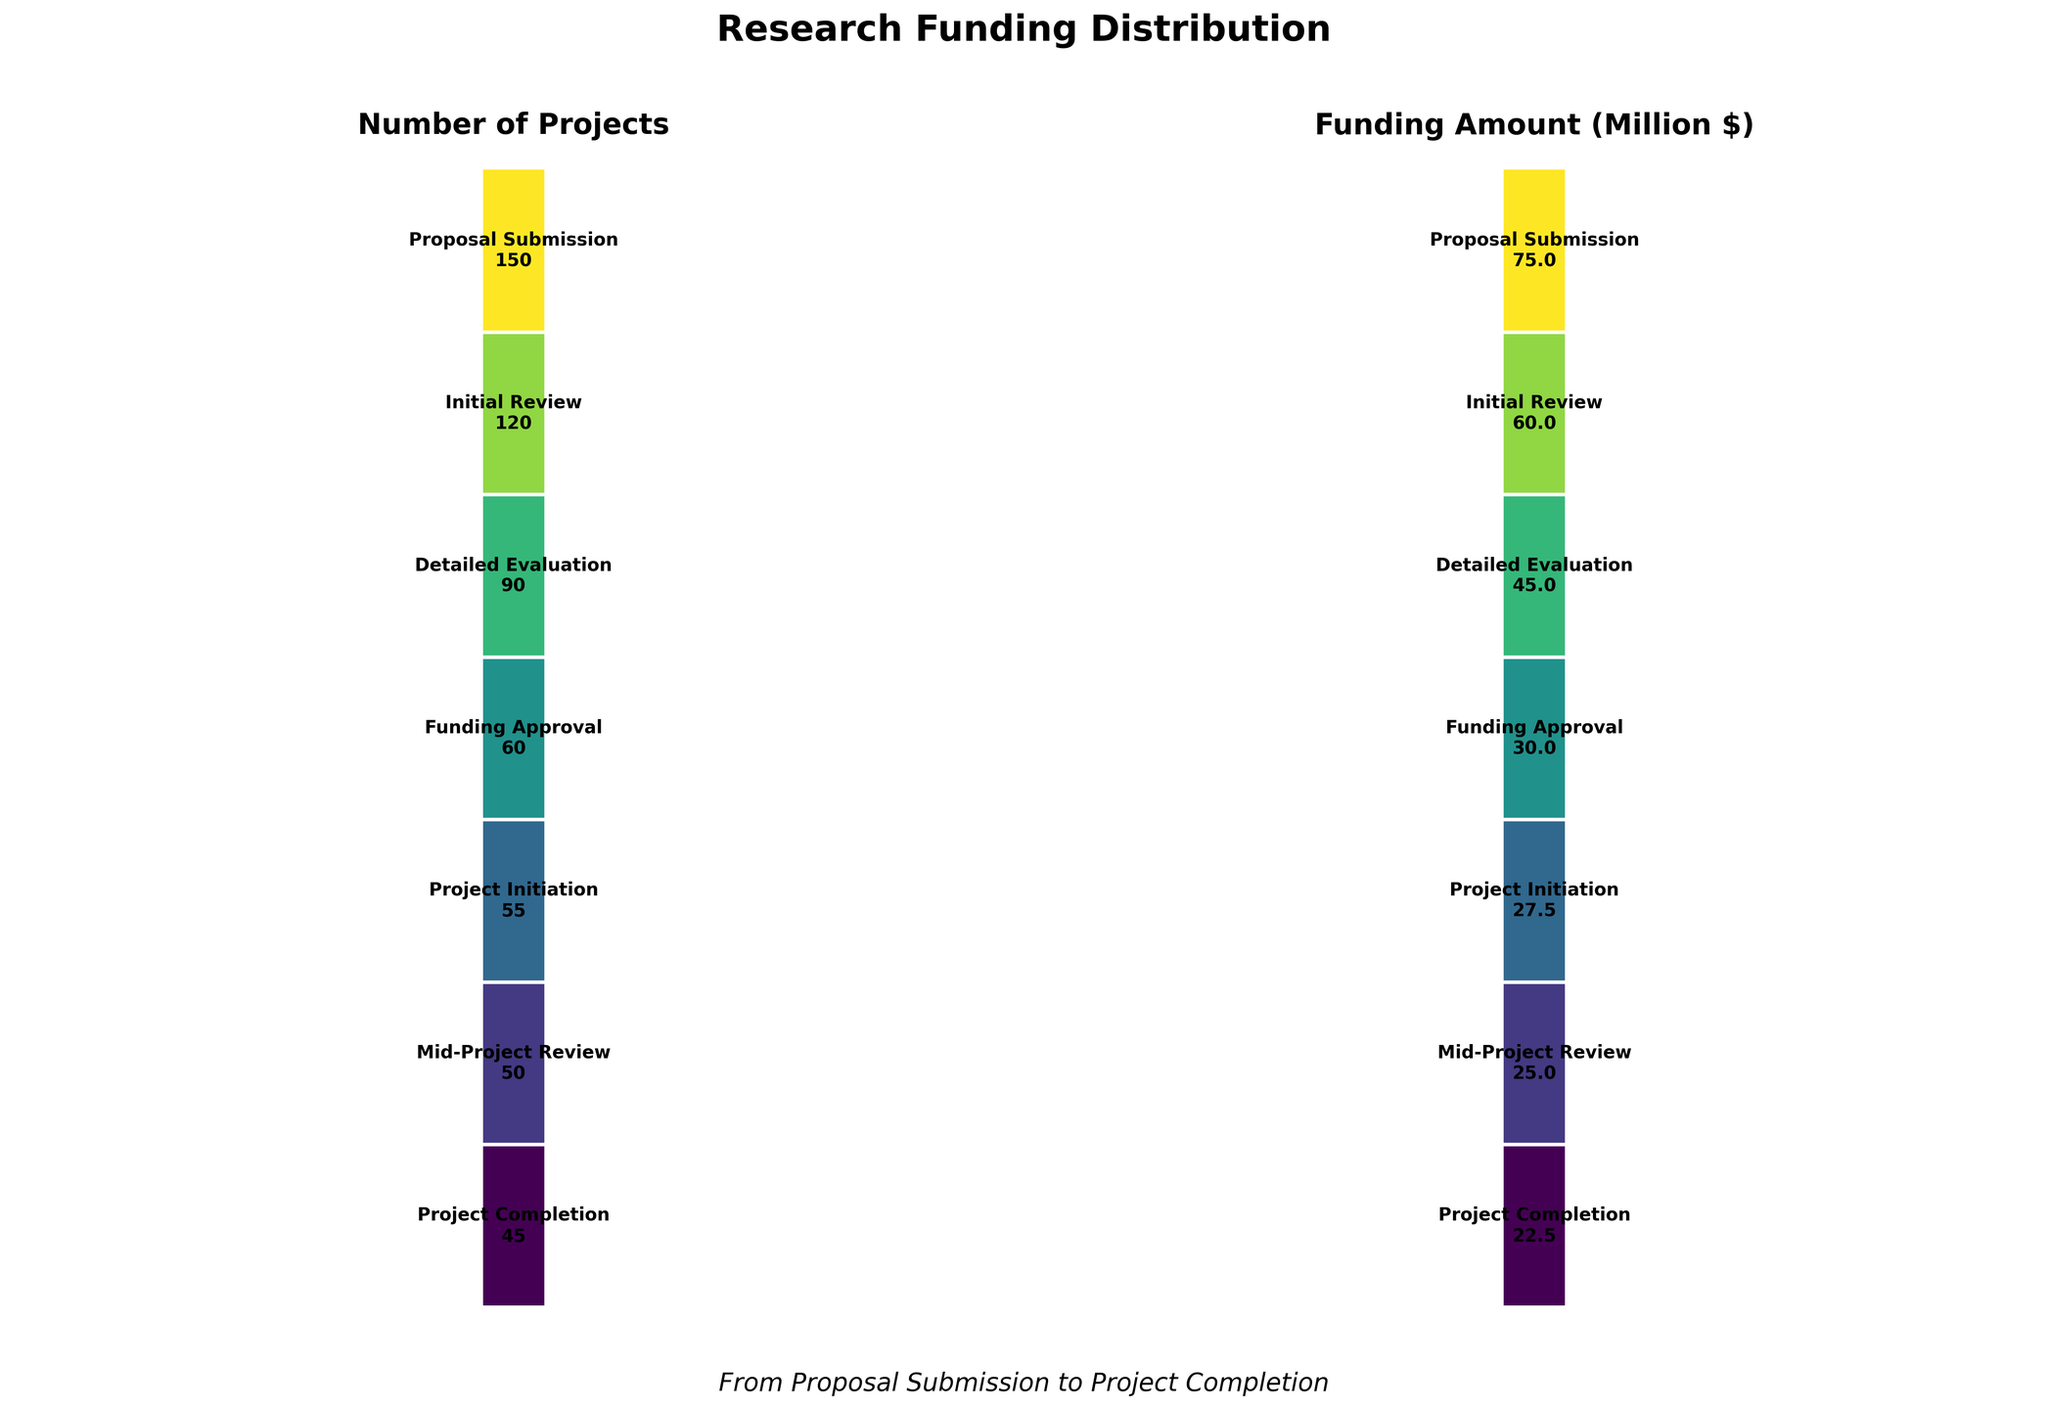What is the title of the figure? The title is prominently displayed at the top of the figure and reads "Research Funding Distribution".
Answer: Research Funding Distribution How many stages are shown in the figure? The figure contains bars for each stage from "Proposal Submission" to "Project Completion". Counting these stages gives a total number of 7 stages.
Answer: 7 What is the amount of funding in million dollars at the "Detailed Evaluation" stage? The funding amount for "Detailed Evaluation" is directly shown on the bar for that stage in the funnel chart for "Funding Amount (Million $)", which is labeled as 45 million dollars.
Answer: 45 million dollars Which stage has the highest number of projects? By looking at the funnel chart for "Number of Projects," the "Proposal Submission" stage has the longest bar, indicating the highest number of projects with 150.
Answer: Proposal Submission At what stage do the number of projects first fall below 100? To determine this, we examine the funnel chart for "Number of Projects". The "Detailed Evaluation" stage has 90 projects, which is the first number below 100.
Answer: Detailed Evaluation What is the difference in the number of projects between the "Initial Review" and the "Project Initiation" stages? The number of projects at the "Initial Review" stage is 120, and at the "Project Initiation" stage is 55. Subtracting these gives 120 - 55 = 65.
Answer: 65 How much total funding is lost from the "Proposal Submission" stage to the "Project Completion" stage? Starting funding is 75 million dollars at the "Proposal Submission" stage and ends at 22.5 million dollars at "Project Completion". The loss is 75 - 22.5 = 52.5 million dollars.
Answer: 52.5 million dollars How many projects reach the "Mid-Project Review" stage after starting at the "Funding Approval" stage? At "Funding Approval", there are 60 projects, and at "Mid-Project Review", there are 50 projects. Subtracting these gives 60 - 50 = 10 projects lost, so 50 projects reach the "Mid-Project Review" stage.
Answer: 50 What is the average funding amount in million dollars across all stages? The total funding amounts at each stage are 75, 60, 45, 30, 27.5, 25, and 22.5 million dollars. Summing these amounts is 75 + 60 + 45 + 30 + 27.5 + 25 + 22.5 = 285 million dollars. There are 7 stages. The average is 285 / 7 = 40.71 million dollars.
Answer: 40.71 million dollars 